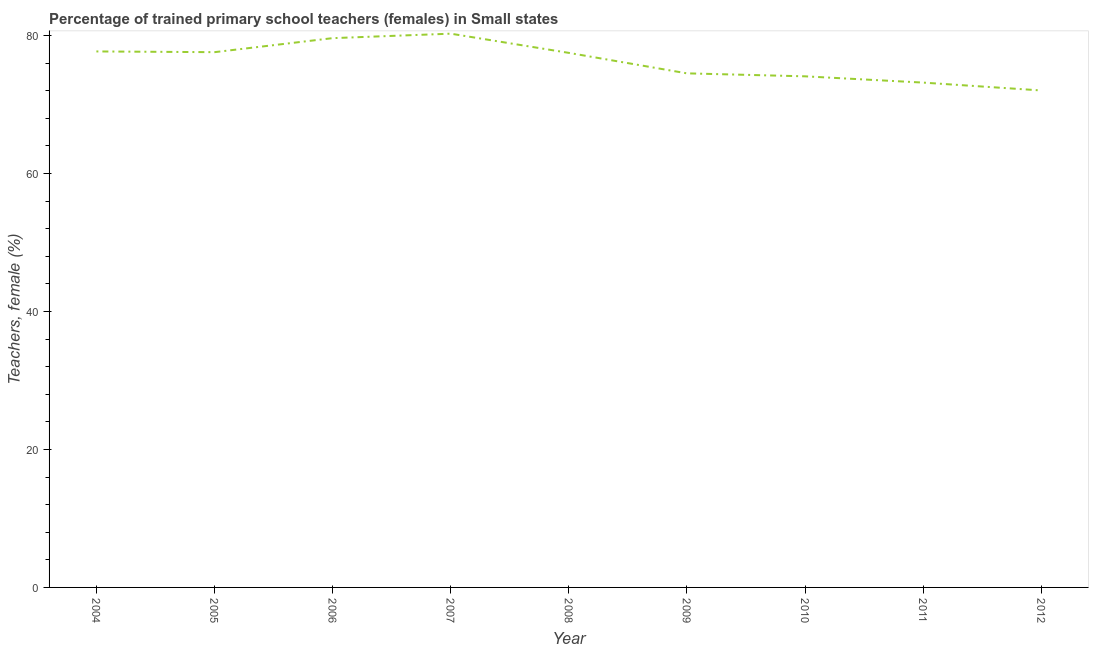What is the percentage of trained female teachers in 2012?
Your answer should be very brief. 72.02. Across all years, what is the maximum percentage of trained female teachers?
Your response must be concise. 80.25. Across all years, what is the minimum percentage of trained female teachers?
Provide a succinct answer. 72.02. In which year was the percentage of trained female teachers maximum?
Your answer should be very brief. 2007. In which year was the percentage of trained female teachers minimum?
Provide a short and direct response. 2012. What is the sum of the percentage of trained female teachers?
Keep it short and to the point. 686.33. What is the difference between the percentage of trained female teachers in 2004 and 2007?
Provide a succinct answer. -2.58. What is the average percentage of trained female teachers per year?
Make the answer very short. 76.26. What is the median percentage of trained female teachers?
Your answer should be very brief. 77.47. In how many years, is the percentage of trained female teachers greater than 24 %?
Offer a terse response. 9. What is the ratio of the percentage of trained female teachers in 2005 to that in 2006?
Offer a very short reply. 0.97. Is the percentage of trained female teachers in 2007 less than that in 2012?
Your answer should be very brief. No. Is the difference between the percentage of trained female teachers in 2004 and 2010 greater than the difference between any two years?
Provide a succinct answer. No. What is the difference between the highest and the second highest percentage of trained female teachers?
Provide a short and direct response. 0.65. Is the sum of the percentage of trained female teachers in 2005 and 2008 greater than the maximum percentage of trained female teachers across all years?
Keep it short and to the point. Yes. What is the difference between the highest and the lowest percentage of trained female teachers?
Offer a very short reply. 8.23. In how many years, is the percentage of trained female teachers greater than the average percentage of trained female teachers taken over all years?
Your response must be concise. 5. How many lines are there?
Your answer should be compact. 1. What is the difference between two consecutive major ticks on the Y-axis?
Keep it short and to the point. 20. Are the values on the major ticks of Y-axis written in scientific E-notation?
Provide a short and direct response. No. Does the graph contain any zero values?
Give a very brief answer. No. What is the title of the graph?
Ensure brevity in your answer.  Percentage of trained primary school teachers (females) in Small states. What is the label or title of the X-axis?
Your response must be concise. Year. What is the label or title of the Y-axis?
Your response must be concise. Teachers, female (%). What is the Teachers, female (%) in 2004?
Offer a terse response. 77.68. What is the Teachers, female (%) of 2005?
Provide a succinct answer. 77.57. What is the Teachers, female (%) of 2006?
Your answer should be very brief. 79.6. What is the Teachers, female (%) in 2007?
Offer a very short reply. 80.25. What is the Teachers, female (%) of 2008?
Your response must be concise. 77.47. What is the Teachers, female (%) of 2009?
Keep it short and to the point. 74.5. What is the Teachers, female (%) of 2010?
Make the answer very short. 74.07. What is the Teachers, female (%) of 2011?
Give a very brief answer. 73.16. What is the Teachers, female (%) in 2012?
Your response must be concise. 72.02. What is the difference between the Teachers, female (%) in 2004 and 2005?
Keep it short and to the point. 0.11. What is the difference between the Teachers, female (%) in 2004 and 2006?
Make the answer very short. -1.93. What is the difference between the Teachers, female (%) in 2004 and 2007?
Keep it short and to the point. -2.58. What is the difference between the Teachers, female (%) in 2004 and 2008?
Provide a short and direct response. 0.21. What is the difference between the Teachers, female (%) in 2004 and 2009?
Make the answer very short. 3.18. What is the difference between the Teachers, female (%) in 2004 and 2010?
Give a very brief answer. 3.61. What is the difference between the Teachers, female (%) in 2004 and 2011?
Provide a succinct answer. 4.52. What is the difference between the Teachers, female (%) in 2004 and 2012?
Ensure brevity in your answer.  5.66. What is the difference between the Teachers, female (%) in 2005 and 2006?
Provide a short and direct response. -2.03. What is the difference between the Teachers, female (%) in 2005 and 2007?
Offer a very short reply. -2.68. What is the difference between the Teachers, female (%) in 2005 and 2008?
Make the answer very short. 0.1. What is the difference between the Teachers, female (%) in 2005 and 2009?
Offer a terse response. 3.07. What is the difference between the Teachers, female (%) in 2005 and 2010?
Provide a succinct answer. 3.5. What is the difference between the Teachers, female (%) in 2005 and 2011?
Your answer should be very brief. 4.41. What is the difference between the Teachers, female (%) in 2005 and 2012?
Make the answer very short. 5.55. What is the difference between the Teachers, female (%) in 2006 and 2007?
Make the answer very short. -0.65. What is the difference between the Teachers, female (%) in 2006 and 2008?
Your answer should be compact. 2.13. What is the difference between the Teachers, female (%) in 2006 and 2009?
Your response must be concise. 5.1. What is the difference between the Teachers, female (%) in 2006 and 2010?
Keep it short and to the point. 5.53. What is the difference between the Teachers, female (%) in 2006 and 2011?
Your answer should be compact. 6.44. What is the difference between the Teachers, female (%) in 2006 and 2012?
Ensure brevity in your answer.  7.58. What is the difference between the Teachers, female (%) in 2007 and 2008?
Offer a terse response. 2.78. What is the difference between the Teachers, female (%) in 2007 and 2009?
Offer a terse response. 5.75. What is the difference between the Teachers, female (%) in 2007 and 2010?
Offer a terse response. 6.18. What is the difference between the Teachers, female (%) in 2007 and 2011?
Provide a succinct answer. 7.09. What is the difference between the Teachers, female (%) in 2007 and 2012?
Provide a succinct answer. 8.23. What is the difference between the Teachers, female (%) in 2008 and 2009?
Give a very brief answer. 2.97. What is the difference between the Teachers, female (%) in 2008 and 2010?
Ensure brevity in your answer.  3.4. What is the difference between the Teachers, female (%) in 2008 and 2011?
Your answer should be compact. 4.31. What is the difference between the Teachers, female (%) in 2008 and 2012?
Give a very brief answer. 5.45. What is the difference between the Teachers, female (%) in 2009 and 2010?
Keep it short and to the point. 0.43. What is the difference between the Teachers, female (%) in 2009 and 2011?
Provide a succinct answer. 1.34. What is the difference between the Teachers, female (%) in 2009 and 2012?
Keep it short and to the point. 2.48. What is the difference between the Teachers, female (%) in 2010 and 2011?
Provide a short and direct response. 0.91. What is the difference between the Teachers, female (%) in 2010 and 2012?
Provide a short and direct response. 2.05. What is the difference between the Teachers, female (%) in 2011 and 2012?
Give a very brief answer. 1.14. What is the ratio of the Teachers, female (%) in 2004 to that in 2005?
Offer a very short reply. 1. What is the ratio of the Teachers, female (%) in 2004 to that in 2008?
Your response must be concise. 1. What is the ratio of the Teachers, female (%) in 2004 to that in 2009?
Offer a very short reply. 1.04. What is the ratio of the Teachers, female (%) in 2004 to that in 2010?
Make the answer very short. 1.05. What is the ratio of the Teachers, female (%) in 2004 to that in 2011?
Ensure brevity in your answer.  1.06. What is the ratio of the Teachers, female (%) in 2004 to that in 2012?
Your answer should be very brief. 1.08. What is the ratio of the Teachers, female (%) in 2005 to that in 2007?
Provide a succinct answer. 0.97. What is the ratio of the Teachers, female (%) in 2005 to that in 2008?
Provide a short and direct response. 1. What is the ratio of the Teachers, female (%) in 2005 to that in 2009?
Provide a succinct answer. 1.04. What is the ratio of the Teachers, female (%) in 2005 to that in 2010?
Offer a terse response. 1.05. What is the ratio of the Teachers, female (%) in 2005 to that in 2011?
Offer a very short reply. 1.06. What is the ratio of the Teachers, female (%) in 2005 to that in 2012?
Provide a short and direct response. 1.08. What is the ratio of the Teachers, female (%) in 2006 to that in 2008?
Ensure brevity in your answer.  1.03. What is the ratio of the Teachers, female (%) in 2006 to that in 2009?
Keep it short and to the point. 1.07. What is the ratio of the Teachers, female (%) in 2006 to that in 2010?
Provide a short and direct response. 1.07. What is the ratio of the Teachers, female (%) in 2006 to that in 2011?
Ensure brevity in your answer.  1.09. What is the ratio of the Teachers, female (%) in 2006 to that in 2012?
Keep it short and to the point. 1.1. What is the ratio of the Teachers, female (%) in 2007 to that in 2008?
Make the answer very short. 1.04. What is the ratio of the Teachers, female (%) in 2007 to that in 2009?
Ensure brevity in your answer.  1.08. What is the ratio of the Teachers, female (%) in 2007 to that in 2010?
Give a very brief answer. 1.08. What is the ratio of the Teachers, female (%) in 2007 to that in 2011?
Offer a terse response. 1.1. What is the ratio of the Teachers, female (%) in 2007 to that in 2012?
Ensure brevity in your answer.  1.11. What is the ratio of the Teachers, female (%) in 2008 to that in 2009?
Your answer should be very brief. 1.04. What is the ratio of the Teachers, female (%) in 2008 to that in 2010?
Make the answer very short. 1.05. What is the ratio of the Teachers, female (%) in 2008 to that in 2011?
Your response must be concise. 1.06. What is the ratio of the Teachers, female (%) in 2008 to that in 2012?
Offer a terse response. 1.08. What is the ratio of the Teachers, female (%) in 2009 to that in 2010?
Ensure brevity in your answer.  1.01. What is the ratio of the Teachers, female (%) in 2009 to that in 2012?
Your answer should be compact. 1.03. What is the ratio of the Teachers, female (%) in 2010 to that in 2012?
Make the answer very short. 1.03. 